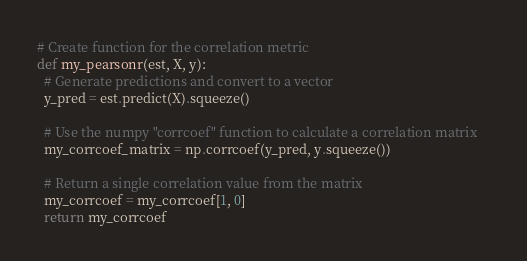<code> <loc_0><loc_0><loc_500><loc_500><_Python_># Create function for the correlation metric
def my_pearsonr(est, X, y):
  # Generate predictions and convert to a vector     
  y_pred = est.predict(X).squeeze()
  
  # Use the numpy "corrcoef" function to calculate a correlation matrix    
  my_corrcoef_matrix = np.corrcoef(y_pred, y.squeeze())
  
  # Return a single correlation value from the matrix    
  my_corrcoef = my_corrcoef[1, 0]
  return my_corrcoef
</code> 